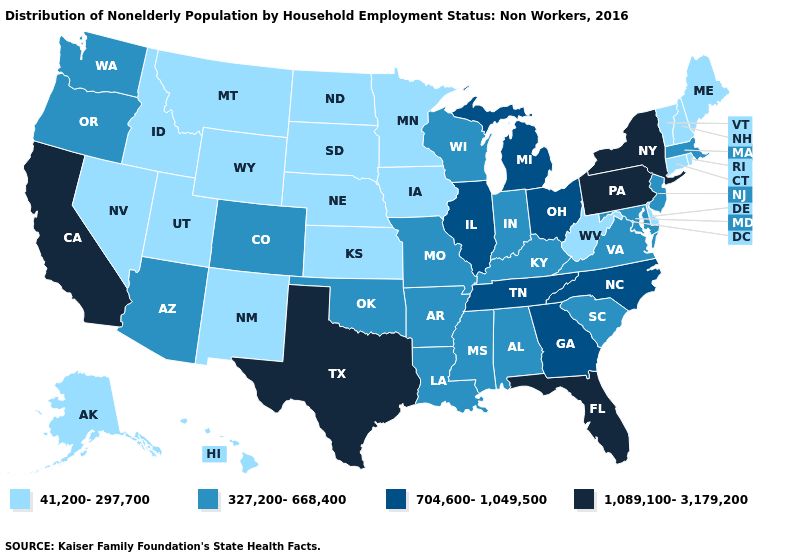Name the states that have a value in the range 704,600-1,049,500?
Keep it brief. Georgia, Illinois, Michigan, North Carolina, Ohio, Tennessee. What is the value of Massachusetts?
Write a very short answer. 327,200-668,400. Does Florida have the highest value in the USA?
Write a very short answer. Yes. Name the states that have a value in the range 1,089,100-3,179,200?
Keep it brief. California, Florida, New York, Pennsylvania, Texas. What is the value of Tennessee?
Quick response, please. 704,600-1,049,500. How many symbols are there in the legend?
Answer briefly. 4. What is the lowest value in the South?
Give a very brief answer. 41,200-297,700. What is the lowest value in states that border Vermont?
Be succinct. 41,200-297,700. What is the value of New Mexico?
Keep it brief. 41,200-297,700. Does Maryland have the same value as Arizona?
Be succinct. Yes. Name the states that have a value in the range 327,200-668,400?
Give a very brief answer. Alabama, Arizona, Arkansas, Colorado, Indiana, Kentucky, Louisiana, Maryland, Massachusetts, Mississippi, Missouri, New Jersey, Oklahoma, Oregon, South Carolina, Virginia, Washington, Wisconsin. Which states hav the highest value in the Northeast?
Give a very brief answer. New York, Pennsylvania. Name the states that have a value in the range 41,200-297,700?
Quick response, please. Alaska, Connecticut, Delaware, Hawaii, Idaho, Iowa, Kansas, Maine, Minnesota, Montana, Nebraska, Nevada, New Hampshire, New Mexico, North Dakota, Rhode Island, South Dakota, Utah, Vermont, West Virginia, Wyoming. Name the states that have a value in the range 41,200-297,700?
Short answer required. Alaska, Connecticut, Delaware, Hawaii, Idaho, Iowa, Kansas, Maine, Minnesota, Montana, Nebraska, Nevada, New Hampshire, New Mexico, North Dakota, Rhode Island, South Dakota, Utah, Vermont, West Virginia, Wyoming. Which states hav the highest value in the South?
Give a very brief answer. Florida, Texas. 